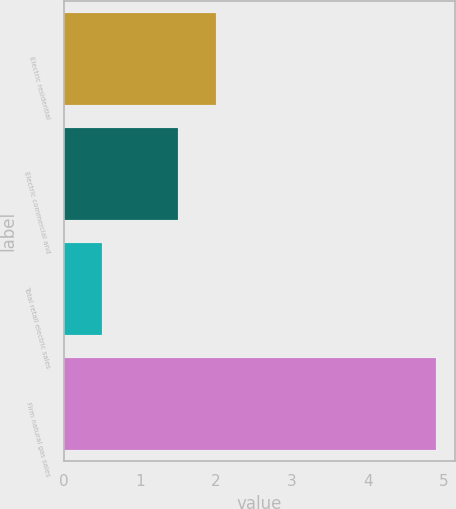Convert chart to OTSL. <chart><loc_0><loc_0><loc_500><loc_500><bar_chart><fcel>Electric residential<fcel>Electric commercial and<fcel>Total retail electric sales<fcel>Firm natural gas sales<nl><fcel>2<fcel>1.5<fcel>0.5<fcel>4.9<nl></chart> 